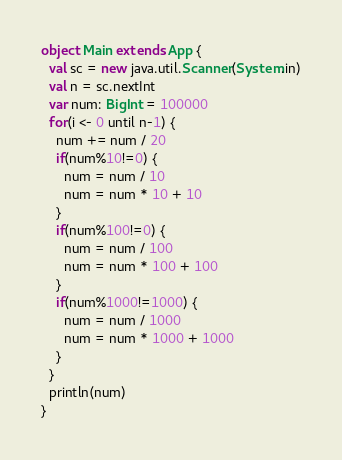<code> <loc_0><loc_0><loc_500><loc_500><_Scala_>object Main extends App {
  val sc = new java.util.Scanner(System.in)
  val n = sc.nextInt
  var num: BigInt = 100000
  for(i <- 0 until n-1) {
    num += num / 20
    if(num%10!=0) {
      num = num / 10
      num = num * 10 + 10
    }
    if(num%100!=0) {
      num = num / 100
      num = num * 100 + 100
    }
    if(num%1000!=1000) {
      num = num / 1000
      num = num * 1000 + 1000
    }
  }
  println(num)
}</code> 